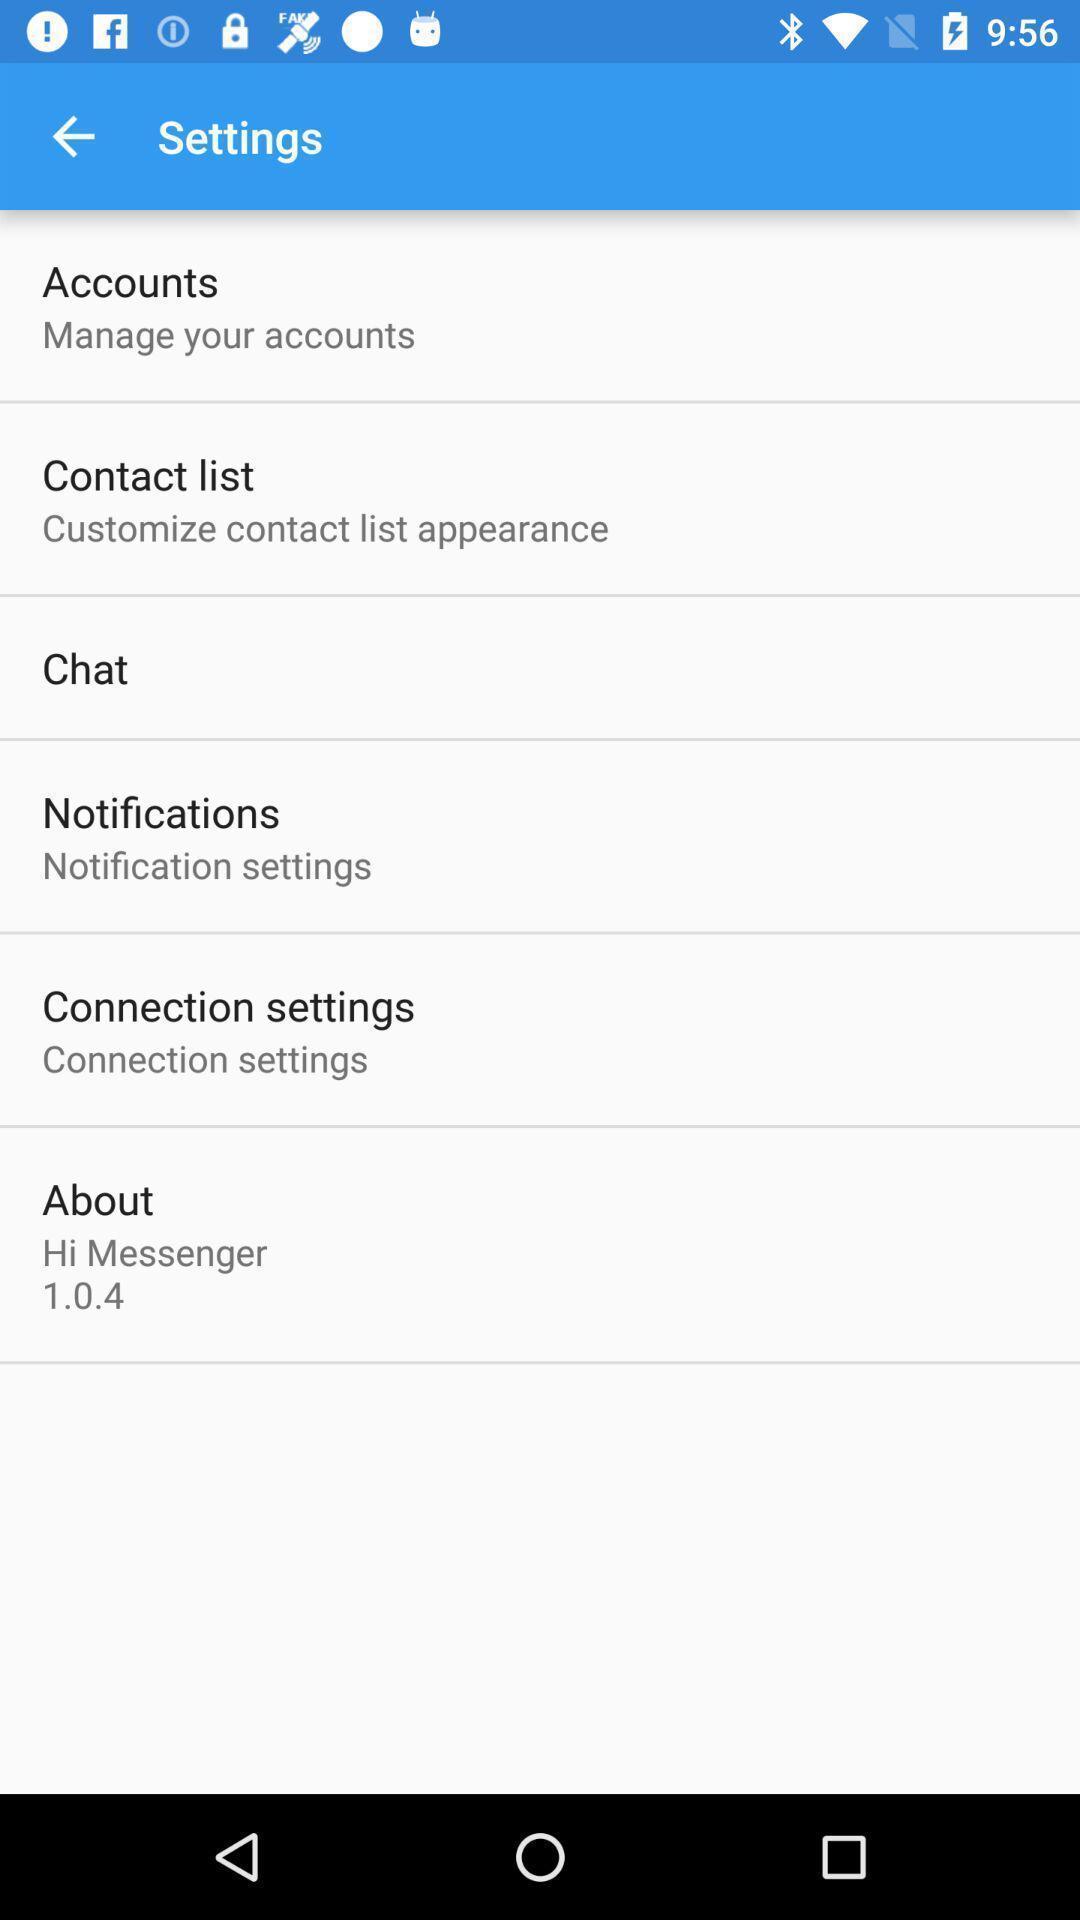Explain the elements present in this screenshot. Page showing various settings options for messaging app. 